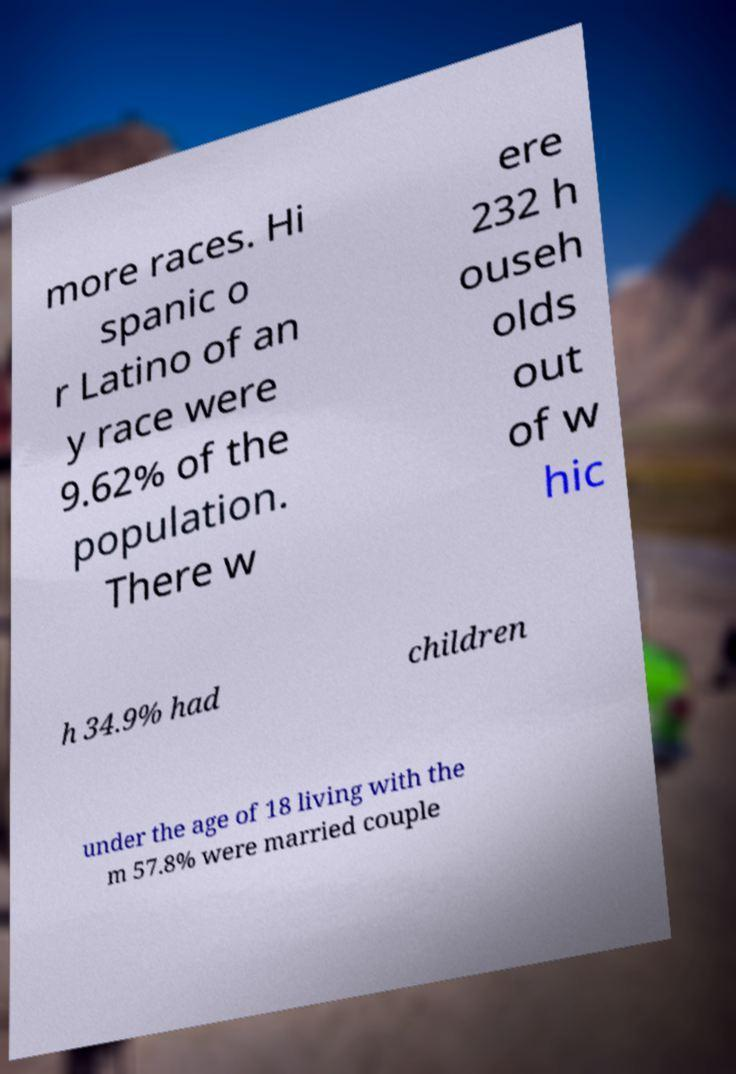Please read and relay the text visible in this image. What does it say? more races. Hi spanic o r Latino of an y race were 9.62% of the population. There w ere 232 h ouseh olds out of w hic h 34.9% had children under the age of 18 living with the m 57.8% were married couple 